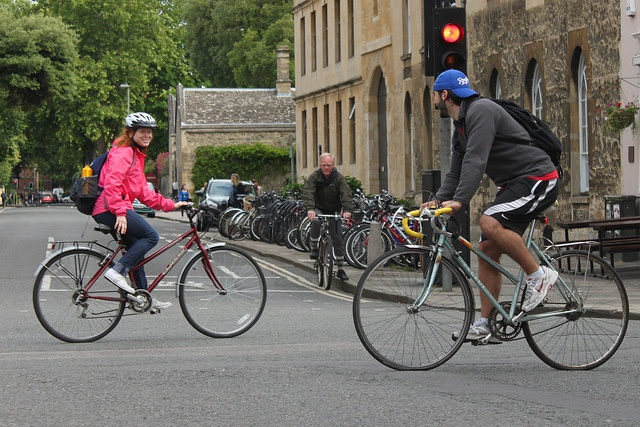Describe the objects in this image and their specific colors. I can see bicycle in olive, gray, and black tones, bicycle in olive, darkgray, black, gray, and maroon tones, people in olive, black, gray, darkgray, and maroon tones, people in olive, black, salmon, brown, and gray tones, and traffic light in olive, black, gray, maroon, and darkgray tones in this image. 